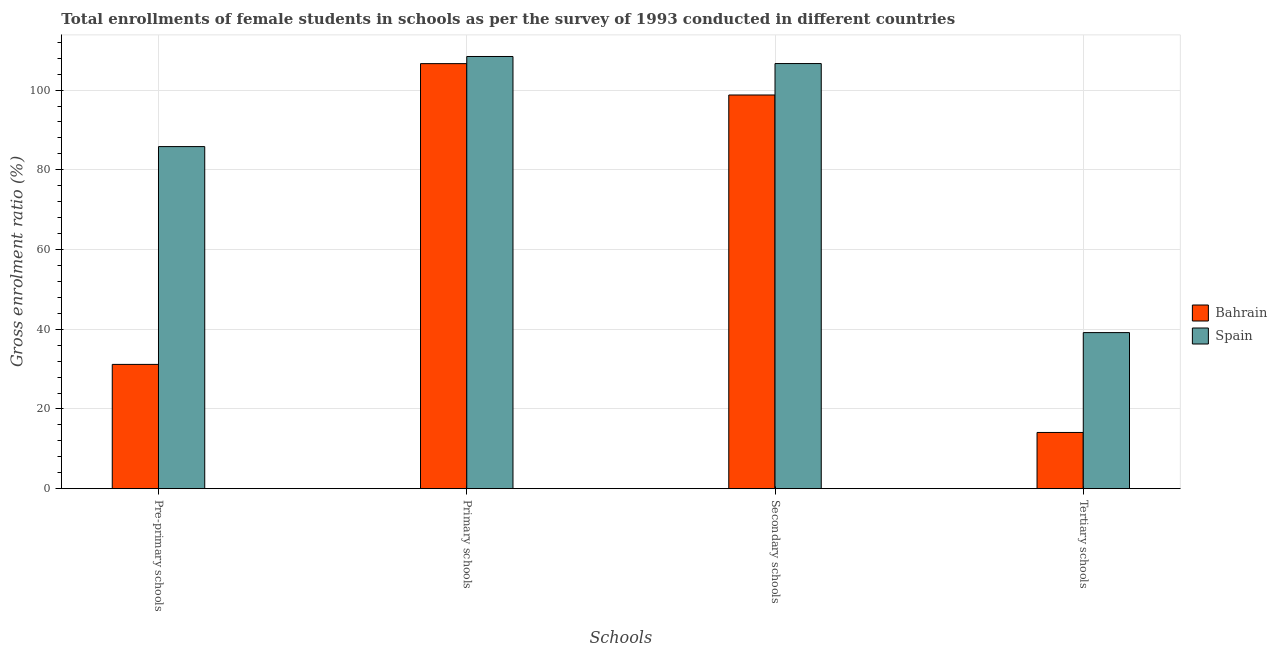What is the label of the 2nd group of bars from the left?
Make the answer very short. Primary schools. What is the gross enrolment ratio(female) in secondary schools in Bahrain?
Offer a very short reply. 98.76. Across all countries, what is the maximum gross enrolment ratio(female) in tertiary schools?
Your answer should be compact. 39.15. Across all countries, what is the minimum gross enrolment ratio(female) in secondary schools?
Your answer should be compact. 98.76. In which country was the gross enrolment ratio(female) in secondary schools maximum?
Provide a short and direct response. Spain. In which country was the gross enrolment ratio(female) in tertiary schools minimum?
Your answer should be compact. Bahrain. What is the total gross enrolment ratio(female) in primary schools in the graph?
Provide a succinct answer. 215.05. What is the difference between the gross enrolment ratio(female) in tertiary schools in Bahrain and that in Spain?
Offer a very short reply. -25.05. What is the difference between the gross enrolment ratio(female) in tertiary schools in Bahrain and the gross enrolment ratio(female) in primary schools in Spain?
Offer a very short reply. -94.32. What is the average gross enrolment ratio(female) in secondary schools per country?
Your answer should be compact. 102.71. What is the difference between the gross enrolment ratio(female) in tertiary schools and gross enrolment ratio(female) in primary schools in Bahrain?
Ensure brevity in your answer.  -92.53. What is the ratio of the gross enrolment ratio(female) in tertiary schools in Bahrain to that in Spain?
Your answer should be very brief. 0.36. What is the difference between the highest and the second highest gross enrolment ratio(female) in primary schools?
Your answer should be very brief. 1.79. What is the difference between the highest and the lowest gross enrolment ratio(female) in tertiary schools?
Your answer should be compact. 25.05. Is the sum of the gross enrolment ratio(female) in secondary schools in Spain and Bahrain greater than the maximum gross enrolment ratio(female) in primary schools across all countries?
Your answer should be compact. Yes. What does the 1st bar from the right in Tertiary schools represents?
Your answer should be very brief. Spain. Is it the case that in every country, the sum of the gross enrolment ratio(female) in pre-primary schools and gross enrolment ratio(female) in primary schools is greater than the gross enrolment ratio(female) in secondary schools?
Your response must be concise. Yes. How many bars are there?
Provide a short and direct response. 8. What is the difference between two consecutive major ticks on the Y-axis?
Your answer should be very brief. 20. Does the graph contain grids?
Keep it short and to the point. Yes. Where does the legend appear in the graph?
Your answer should be compact. Center right. How many legend labels are there?
Offer a terse response. 2. How are the legend labels stacked?
Your response must be concise. Vertical. What is the title of the graph?
Provide a succinct answer. Total enrollments of female students in schools as per the survey of 1993 conducted in different countries. What is the label or title of the X-axis?
Keep it short and to the point. Schools. What is the Gross enrolment ratio (%) of Bahrain in Pre-primary schools?
Keep it short and to the point. 31.18. What is the Gross enrolment ratio (%) of Spain in Pre-primary schools?
Keep it short and to the point. 85.82. What is the Gross enrolment ratio (%) of Bahrain in Primary schools?
Ensure brevity in your answer.  106.63. What is the Gross enrolment ratio (%) in Spain in Primary schools?
Your answer should be compact. 108.42. What is the Gross enrolment ratio (%) of Bahrain in Secondary schools?
Offer a very short reply. 98.76. What is the Gross enrolment ratio (%) in Spain in Secondary schools?
Provide a short and direct response. 106.65. What is the Gross enrolment ratio (%) in Bahrain in Tertiary schools?
Ensure brevity in your answer.  14.1. What is the Gross enrolment ratio (%) of Spain in Tertiary schools?
Provide a succinct answer. 39.15. Across all Schools, what is the maximum Gross enrolment ratio (%) of Bahrain?
Keep it short and to the point. 106.63. Across all Schools, what is the maximum Gross enrolment ratio (%) of Spain?
Provide a short and direct response. 108.42. Across all Schools, what is the minimum Gross enrolment ratio (%) of Bahrain?
Your response must be concise. 14.1. Across all Schools, what is the minimum Gross enrolment ratio (%) of Spain?
Your answer should be very brief. 39.15. What is the total Gross enrolment ratio (%) in Bahrain in the graph?
Give a very brief answer. 250.67. What is the total Gross enrolment ratio (%) of Spain in the graph?
Your response must be concise. 340.04. What is the difference between the Gross enrolment ratio (%) in Bahrain in Pre-primary schools and that in Primary schools?
Your response must be concise. -75.46. What is the difference between the Gross enrolment ratio (%) in Spain in Pre-primary schools and that in Primary schools?
Provide a succinct answer. -22.6. What is the difference between the Gross enrolment ratio (%) of Bahrain in Pre-primary schools and that in Secondary schools?
Ensure brevity in your answer.  -67.59. What is the difference between the Gross enrolment ratio (%) in Spain in Pre-primary schools and that in Secondary schools?
Make the answer very short. -20.83. What is the difference between the Gross enrolment ratio (%) in Bahrain in Pre-primary schools and that in Tertiary schools?
Your response must be concise. 17.07. What is the difference between the Gross enrolment ratio (%) of Spain in Pre-primary schools and that in Tertiary schools?
Offer a very short reply. 46.67. What is the difference between the Gross enrolment ratio (%) of Bahrain in Primary schools and that in Secondary schools?
Your answer should be very brief. 7.87. What is the difference between the Gross enrolment ratio (%) in Spain in Primary schools and that in Secondary schools?
Make the answer very short. 1.77. What is the difference between the Gross enrolment ratio (%) of Bahrain in Primary schools and that in Tertiary schools?
Give a very brief answer. 92.53. What is the difference between the Gross enrolment ratio (%) of Spain in Primary schools and that in Tertiary schools?
Make the answer very short. 69.27. What is the difference between the Gross enrolment ratio (%) in Bahrain in Secondary schools and that in Tertiary schools?
Provide a short and direct response. 84.66. What is the difference between the Gross enrolment ratio (%) in Spain in Secondary schools and that in Tertiary schools?
Provide a succinct answer. 67.5. What is the difference between the Gross enrolment ratio (%) of Bahrain in Pre-primary schools and the Gross enrolment ratio (%) of Spain in Primary schools?
Offer a very short reply. -77.25. What is the difference between the Gross enrolment ratio (%) in Bahrain in Pre-primary schools and the Gross enrolment ratio (%) in Spain in Secondary schools?
Offer a very short reply. -75.47. What is the difference between the Gross enrolment ratio (%) in Bahrain in Pre-primary schools and the Gross enrolment ratio (%) in Spain in Tertiary schools?
Ensure brevity in your answer.  -7.98. What is the difference between the Gross enrolment ratio (%) in Bahrain in Primary schools and the Gross enrolment ratio (%) in Spain in Secondary schools?
Offer a terse response. -0.02. What is the difference between the Gross enrolment ratio (%) of Bahrain in Primary schools and the Gross enrolment ratio (%) of Spain in Tertiary schools?
Your answer should be very brief. 67.48. What is the difference between the Gross enrolment ratio (%) in Bahrain in Secondary schools and the Gross enrolment ratio (%) in Spain in Tertiary schools?
Provide a short and direct response. 59.61. What is the average Gross enrolment ratio (%) in Bahrain per Schools?
Provide a succinct answer. 62.67. What is the average Gross enrolment ratio (%) of Spain per Schools?
Offer a very short reply. 85.01. What is the difference between the Gross enrolment ratio (%) of Bahrain and Gross enrolment ratio (%) of Spain in Pre-primary schools?
Make the answer very short. -54.64. What is the difference between the Gross enrolment ratio (%) of Bahrain and Gross enrolment ratio (%) of Spain in Primary schools?
Your answer should be compact. -1.79. What is the difference between the Gross enrolment ratio (%) of Bahrain and Gross enrolment ratio (%) of Spain in Secondary schools?
Provide a short and direct response. -7.89. What is the difference between the Gross enrolment ratio (%) in Bahrain and Gross enrolment ratio (%) in Spain in Tertiary schools?
Ensure brevity in your answer.  -25.05. What is the ratio of the Gross enrolment ratio (%) of Bahrain in Pre-primary schools to that in Primary schools?
Make the answer very short. 0.29. What is the ratio of the Gross enrolment ratio (%) in Spain in Pre-primary schools to that in Primary schools?
Offer a very short reply. 0.79. What is the ratio of the Gross enrolment ratio (%) of Bahrain in Pre-primary schools to that in Secondary schools?
Provide a short and direct response. 0.32. What is the ratio of the Gross enrolment ratio (%) in Spain in Pre-primary schools to that in Secondary schools?
Offer a very short reply. 0.8. What is the ratio of the Gross enrolment ratio (%) of Bahrain in Pre-primary schools to that in Tertiary schools?
Provide a succinct answer. 2.21. What is the ratio of the Gross enrolment ratio (%) in Spain in Pre-primary schools to that in Tertiary schools?
Your answer should be compact. 2.19. What is the ratio of the Gross enrolment ratio (%) of Bahrain in Primary schools to that in Secondary schools?
Keep it short and to the point. 1.08. What is the ratio of the Gross enrolment ratio (%) in Spain in Primary schools to that in Secondary schools?
Your response must be concise. 1.02. What is the ratio of the Gross enrolment ratio (%) of Bahrain in Primary schools to that in Tertiary schools?
Provide a short and direct response. 7.56. What is the ratio of the Gross enrolment ratio (%) in Spain in Primary schools to that in Tertiary schools?
Your response must be concise. 2.77. What is the ratio of the Gross enrolment ratio (%) of Bahrain in Secondary schools to that in Tertiary schools?
Provide a short and direct response. 7. What is the ratio of the Gross enrolment ratio (%) in Spain in Secondary schools to that in Tertiary schools?
Provide a succinct answer. 2.72. What is the difference between the highest and the second highest Gross enrolment ratio (%) of Bahrain?
Ensure brevity in your answer.  7.87. What is the difference between the highest and the second highest Gross enrolment ratio (%) in Spain?
Your answer should be very brief. 1.77. What is the difference between the highest and the lowest Gross enrolment ratio (%) of Bahrain?
Make the answer very short. 92.53. What is the difference between the highest and the lowest Gross enrolment ratio (%) in Spain?
Keep it short and to the point. 69.27. 